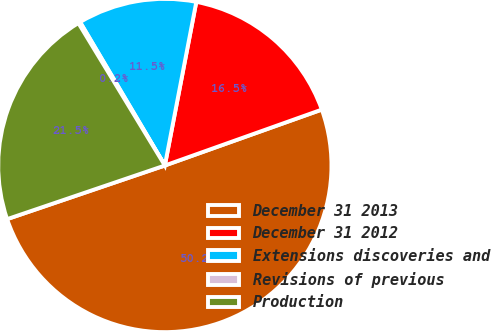Convert chart. <chart><loc_0><loc_0><loc_500><loc_500><pie_chart><fcel>December 31 2013<fcel>December 31 2012<fcel>Extensions discoveries and<fcel>Revisions of previous<fcel>Production<nl><fcel>50.23%<fcel>16.53%<fcel>11.52%<fcel>0.19%<fcel>21.53%<nl></chart> 